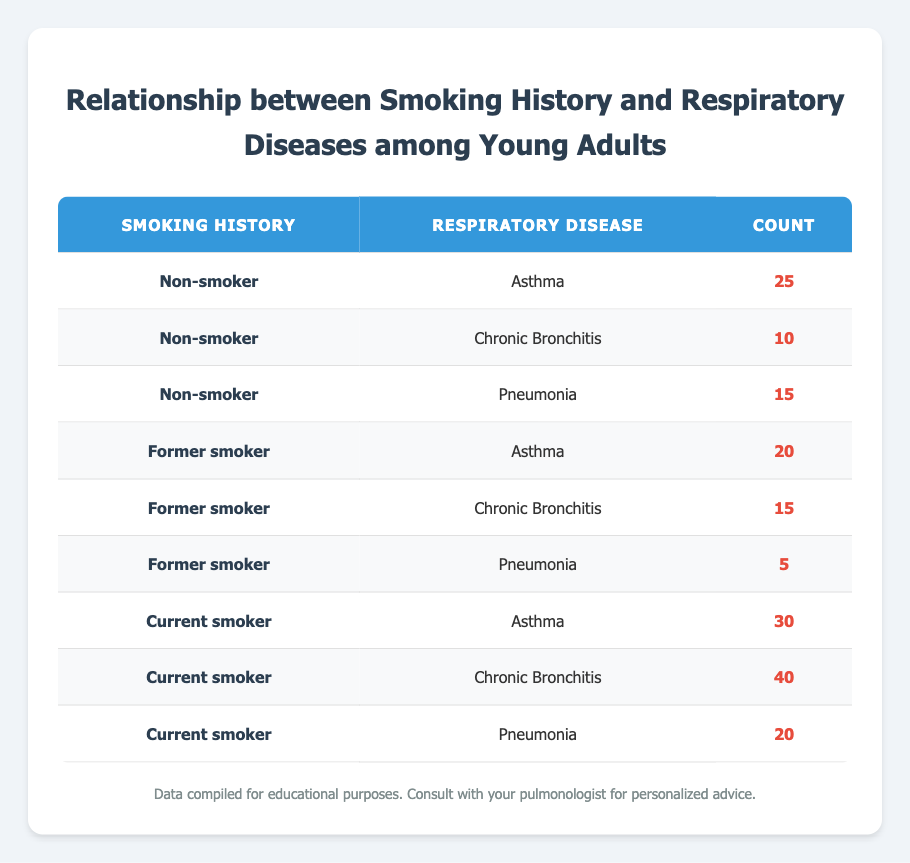What is the count of young adults who have been diagnosed with asthma and are current smokers? From the table, locate the row where the smoking history is "Current smoker" and the diagnosed respiratory disease is "Asthma." The count in that row is 30.
Answer: 30 How many young adults are diagnosed with chronic bronchitis among former smokers? Look at the row where the smoking history is "Former smoker" and find the count for "Chronic Bronchitis." The count provided in that row is 15.
Answer: 15 What is the total number of young adults diagnosed with pneumonia across all smoking histories? To find this, sum the counts of pneumonia in all relevant rows: Non-smokers (15), Former smokers (5), and Current smokers (20). The total is 15 + 5 + 20 = 40.
Answer: 40 Are more current smokers diagnosed with chronic bronchitis than non-smokers? Compare the counts: Current smokers diagnosed with chronic bronchitis is 40, while non-smokers have a count of 10. Since 40 is greater than 10, the statement is true.
Answer: Yes What proportion of smokers (current and former) has been diagnosed with asthma? First, find the total number of diagnosed asthma cases among smokers: Former smokers (20) + Current smokers (30) = 50. Next, find the total number of diagnosed cases for both smoking groups: Former smokers (20 + 15 + 5 = 40) + Current smokers (30 + 40 + 20 = 90) = 130. The proportion is 50 / 130, which simplifies approximately to 0.384 or 38.4%.
Answer: 38.4% Which group has the lowest diagnosed disease count and what is that count? Check each group: Non-smoker with Chronic Bronchitis = 10, Former smoker with Pneumonia = 5, Current smoker with Pneumonia = 20. The lowest count is 5 for Former smokers and Pneumonia.
Answer: 5 Is there a higher count of asthma cases among smokers compared to non-smokers? Calculate the total asthma cases for smokers: Former smokers (20) + Current smokers (30) = 50. The count for non-smokers diagnosed with asthma is 25. Since 50 is greater than 25, the answer is yes.
Answer: Yes What is the average number of diagnosed respiratory diseases among current smokers? To find the average, add the counts for current smokers: Asthma (30) + Chronic Bronchitis (40) + Pneumonia (20) = 90. There are 3 categories, so the average is 90 / 3 = 30.
Answer: 30 How many more cases of chronic bronchitis exist among current smokers than former smokers? Find the count for current smokers with chronic bronchitis, which is 40, and for former smokers, which is 15. The difference is 40 - 15 = 25.
Answer: 25 